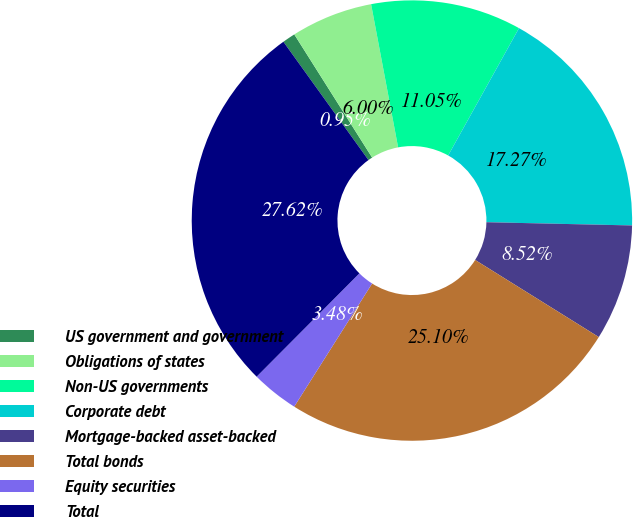Convert chart to OTSL. <chart><loc_0><loc_0><loc_500><loc_500><pie_chart><fcel>US government and government<fcel>Obligations of states<fcel>Non-US governments<fcel>Corporate debt<fcel>Mortgage-backed asset-backed<fcel>Total bonds<fcel>Equity securities<fcel>Total<nl><fcel>0.95%<fcel>6.0%<fcel>11.05%<fcel>17.27%<fcel>8.52%<fcel>25.1%<fcel>3.48%<fcel>27.62%<nl></chart> 